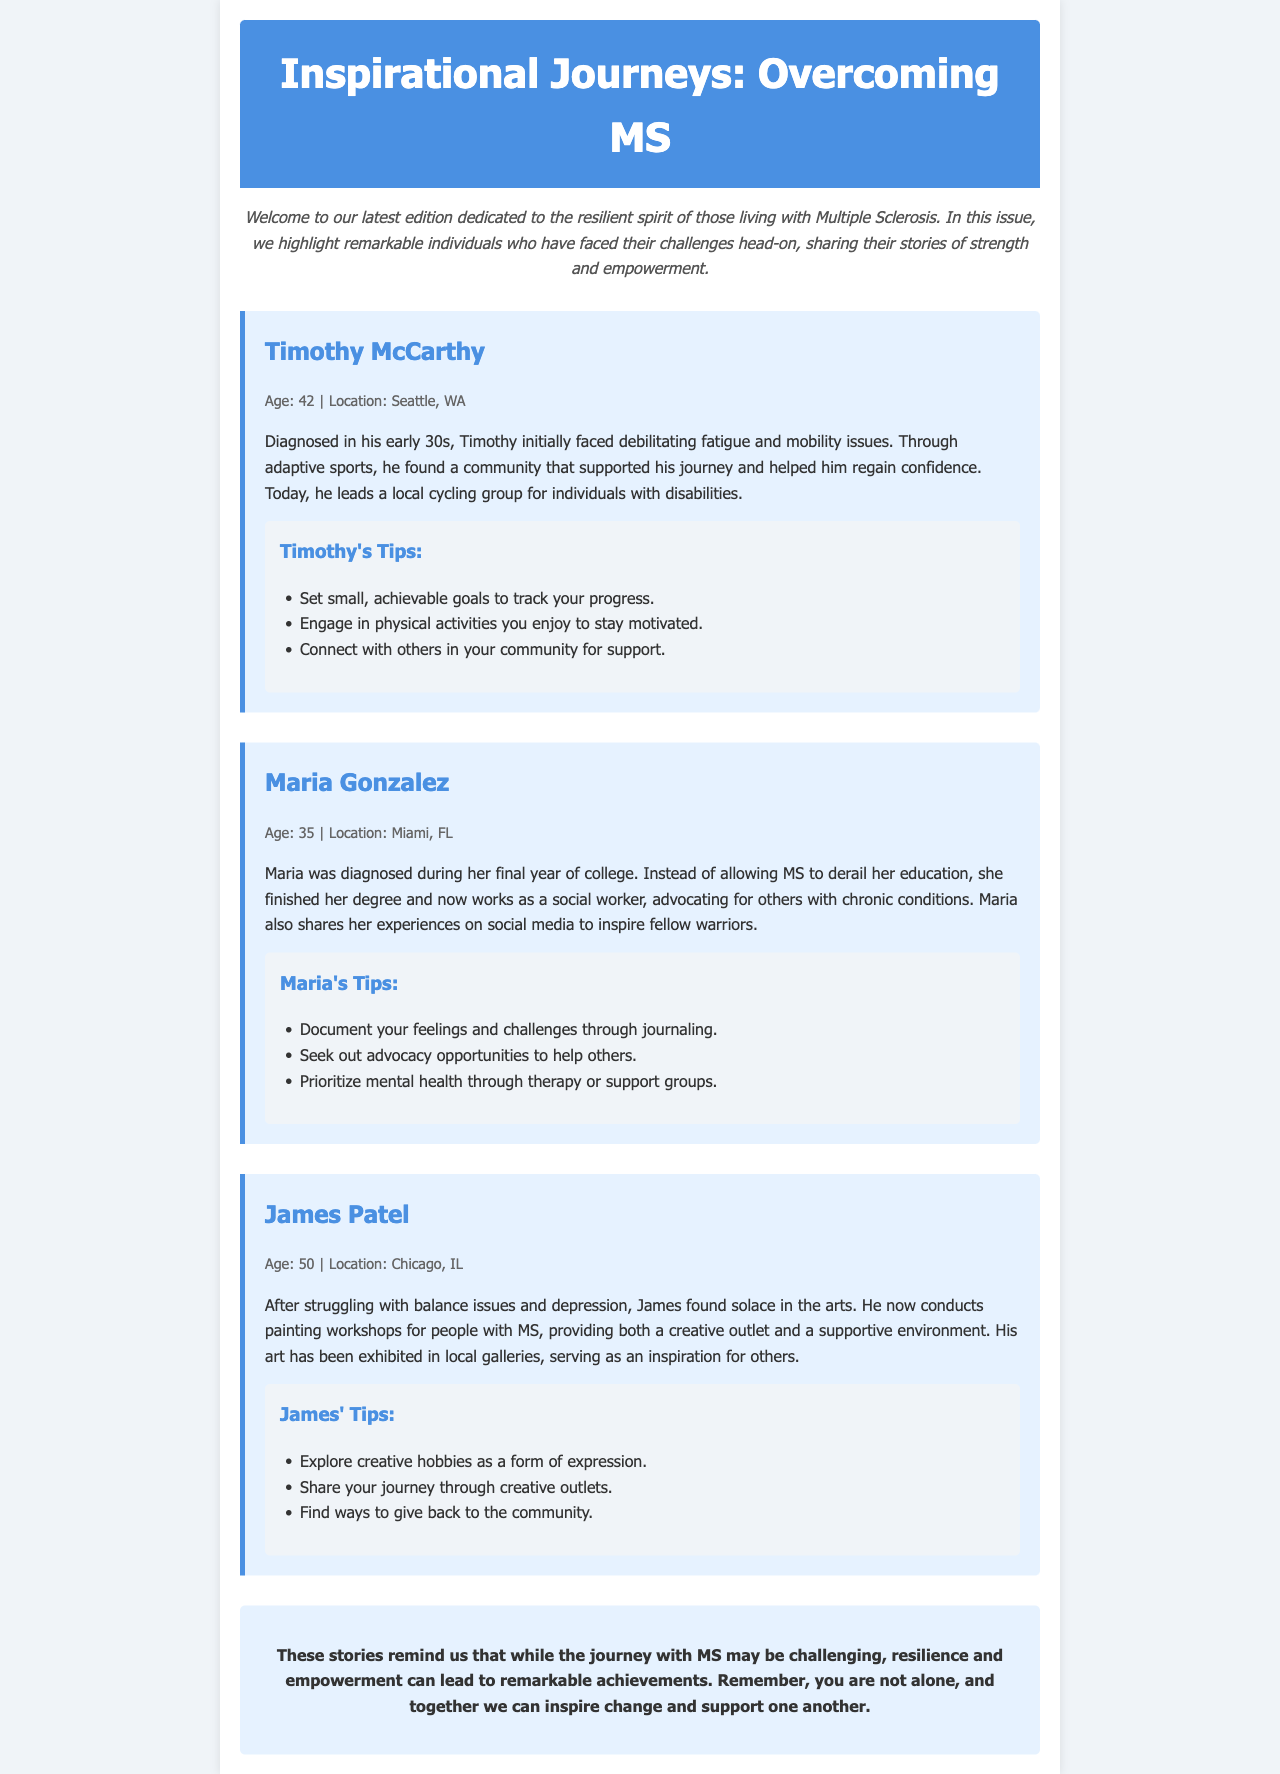What is the title of the newsletter? The title of the newsletter is displayed prominently at the top of the document.
Answer: Inspirational Journeys: Overcoming MS How many individuals are featured in the document? There are three individuals discussed in the newsletter, each sharing their story.
Answer: Three What age was Timothy McCarthy when diagnosed? The document states Timothy's age and mentions his diagnosis during his early 30s.
Answer: Early 30s What city is Maria Gonzalez from? The location of Maria is given in the story section, identifying her city.
Answer: Miami, FL Which activity helped Timothy regain confidence? The document highlights adaptive sports as a critical factor in Timothy's empowerment.
Answer: Adaptive sports What type of advocacy does Maria participate in? Maria works as a social worker, and the document mentions her advocacy efforts for those with chronic conditions.
Answer: Advocacy for others with chronic conditions What creative outlet does James Patel pursue? The newsletter discusses James conducting painting workshops, which serves as his creative outlet.
Answer: Painting What is one of Timothy's tips for resilience? Timothy's suggestions for building resilience are specifically stated in the tips section under his profile.
Answer: Set small, achievable goals What is the overall theme of this newsletter? The theme of the newsletter centers on resilience and empowerment among those living with Multiple Sclerosis.
Answer: Resilience and empowerment 